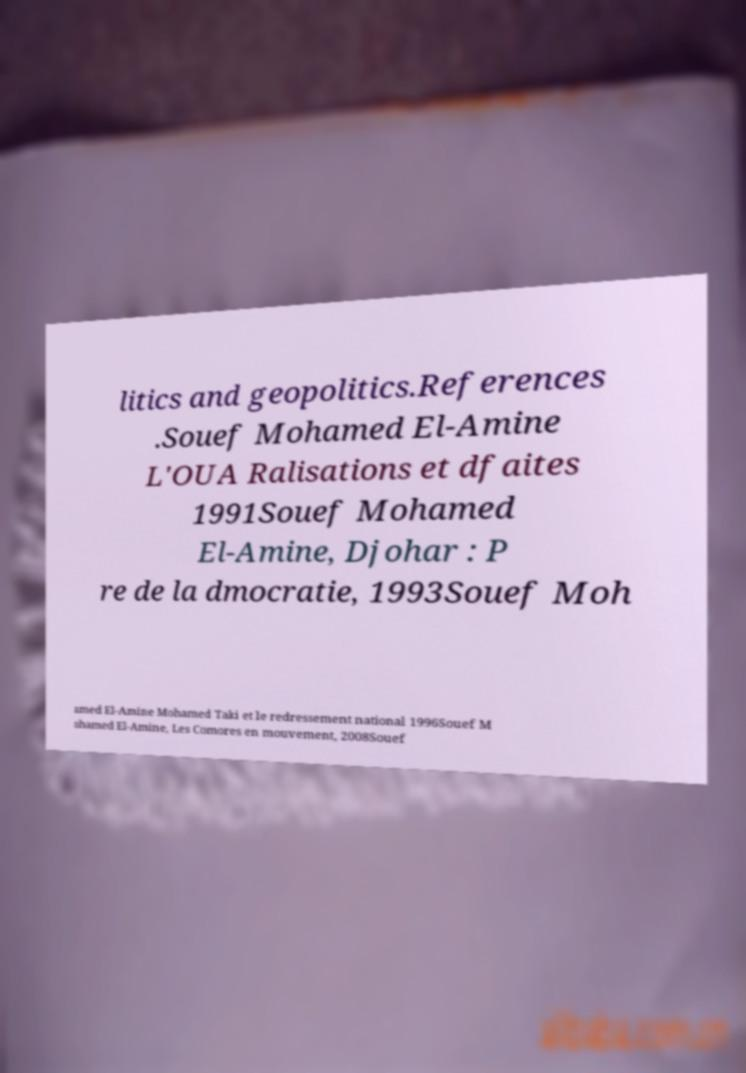Please read and relay the text visible in this image. What does it say? litics and geopolitics.References .Souef Mohamed El-Amine L'OUA Ralisations et dfaites 1991Souef Mohamed El-Amine, Djohar : P re de la dmocratie, 1993Souef Moh amed El-Amine Mohamed Taki et le redressement national 1996Souef M ohamed El-Amine, Les Comores en mouvement, 2008Souef 